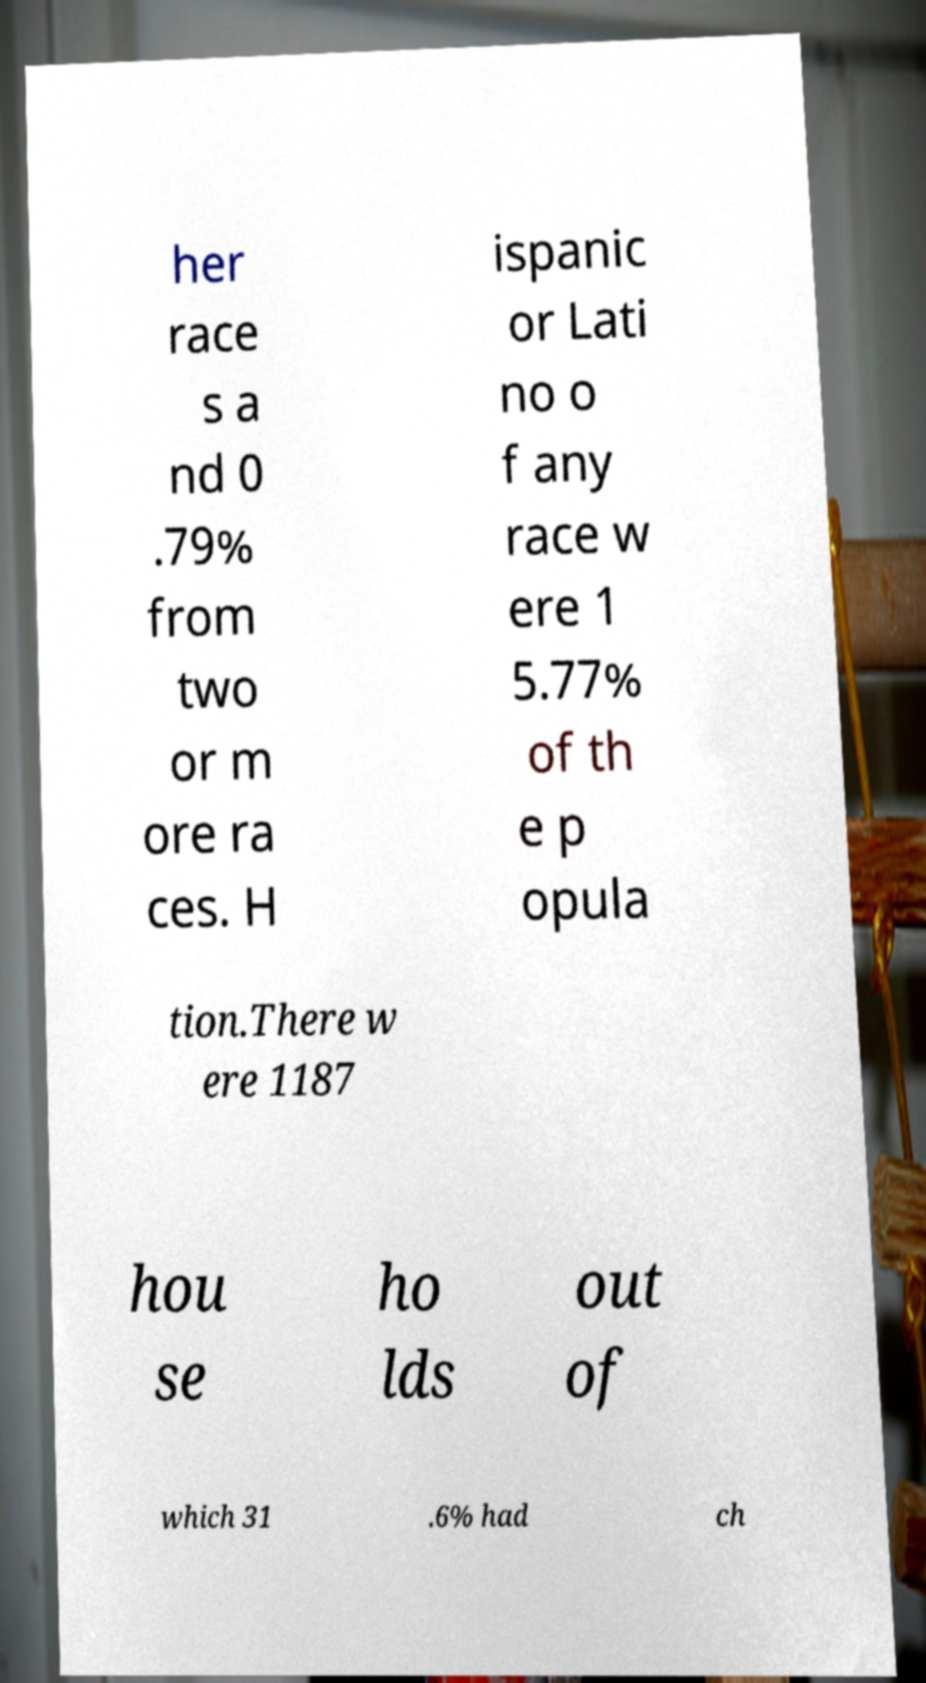Can you read and provide the text displayed in the image?This photo seems to have some interesting text. Can you extract and type it out for me? her race s a nd 0 .79% from two or m ore ra ces. H ispanic or Lati no o f any race w ere 1 5.77% of th e p opula tion.There w ere 1187 hou se ho lds out of which 31 .6% had ch 